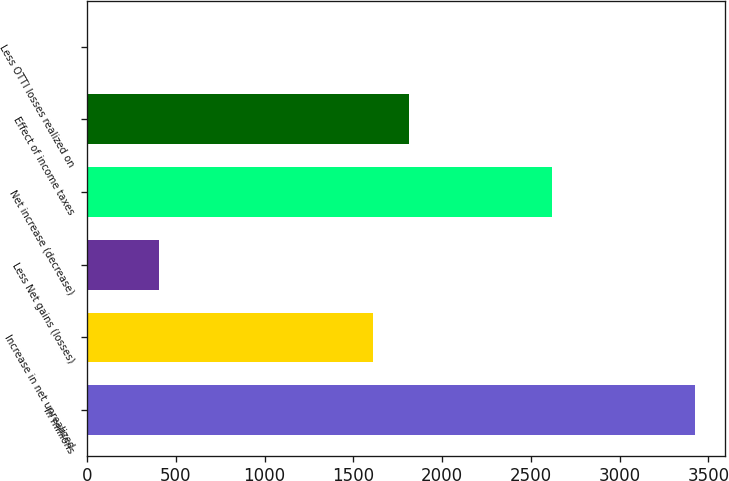<chart> <loc_0><loc_0><loc_500><loc_500><bar_chart><fcel>In millions<fcel>Increase in net unrealized<fcel>Less Net gains (losses)<fcel>Net increase (decrease)<fcel>Effect of income taxes<fcel>Less OTTI losses realized on<nl><fcel>3425.8<fcel>1613.2<fcel>404.8<fcel>2620.2<fcel>1814.6<fcel>2<nl></chart> 